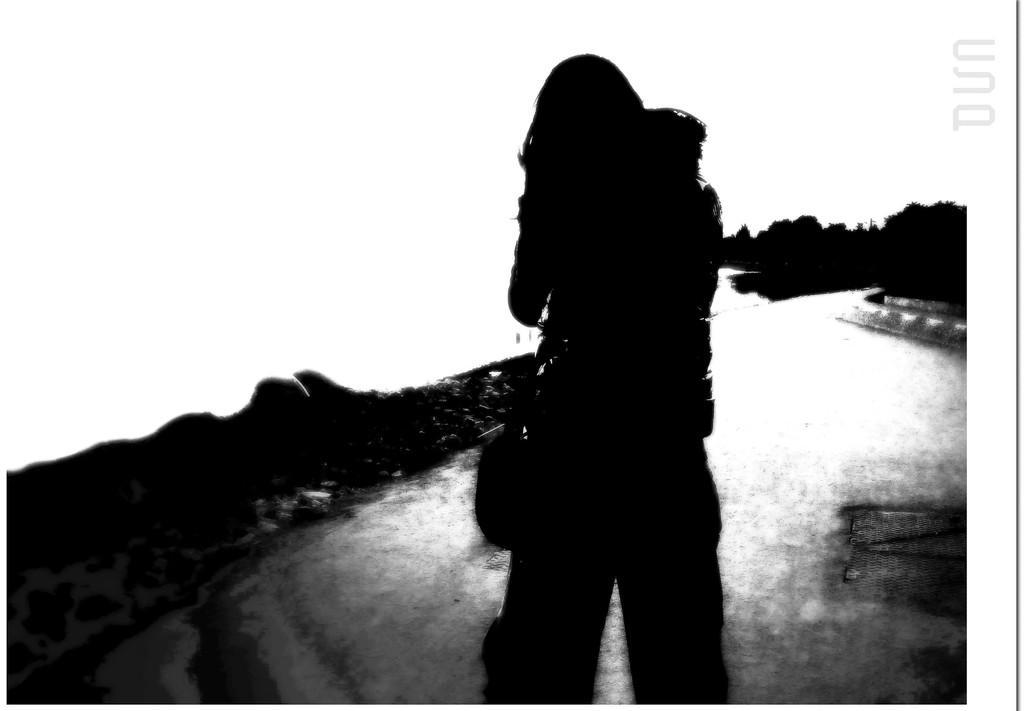Can you describe this image briefly? In this picture we can see a person and in the background we can see trees. 